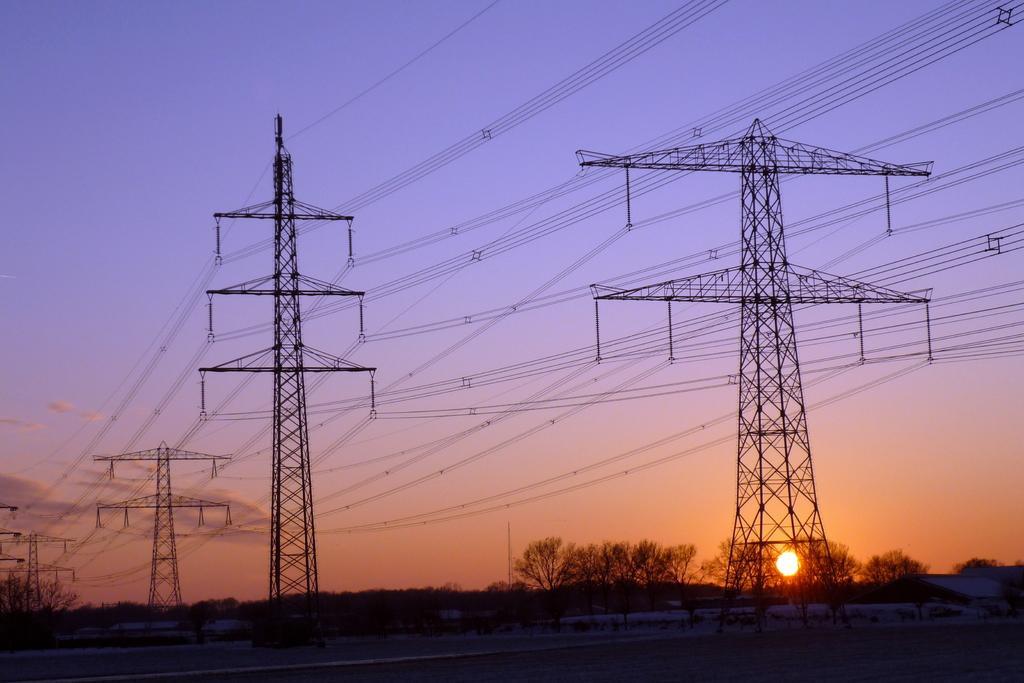Describe this image in one or two sentences. In this image in the background there are trees, towers and there are wires on the towers and the sun is visible. 